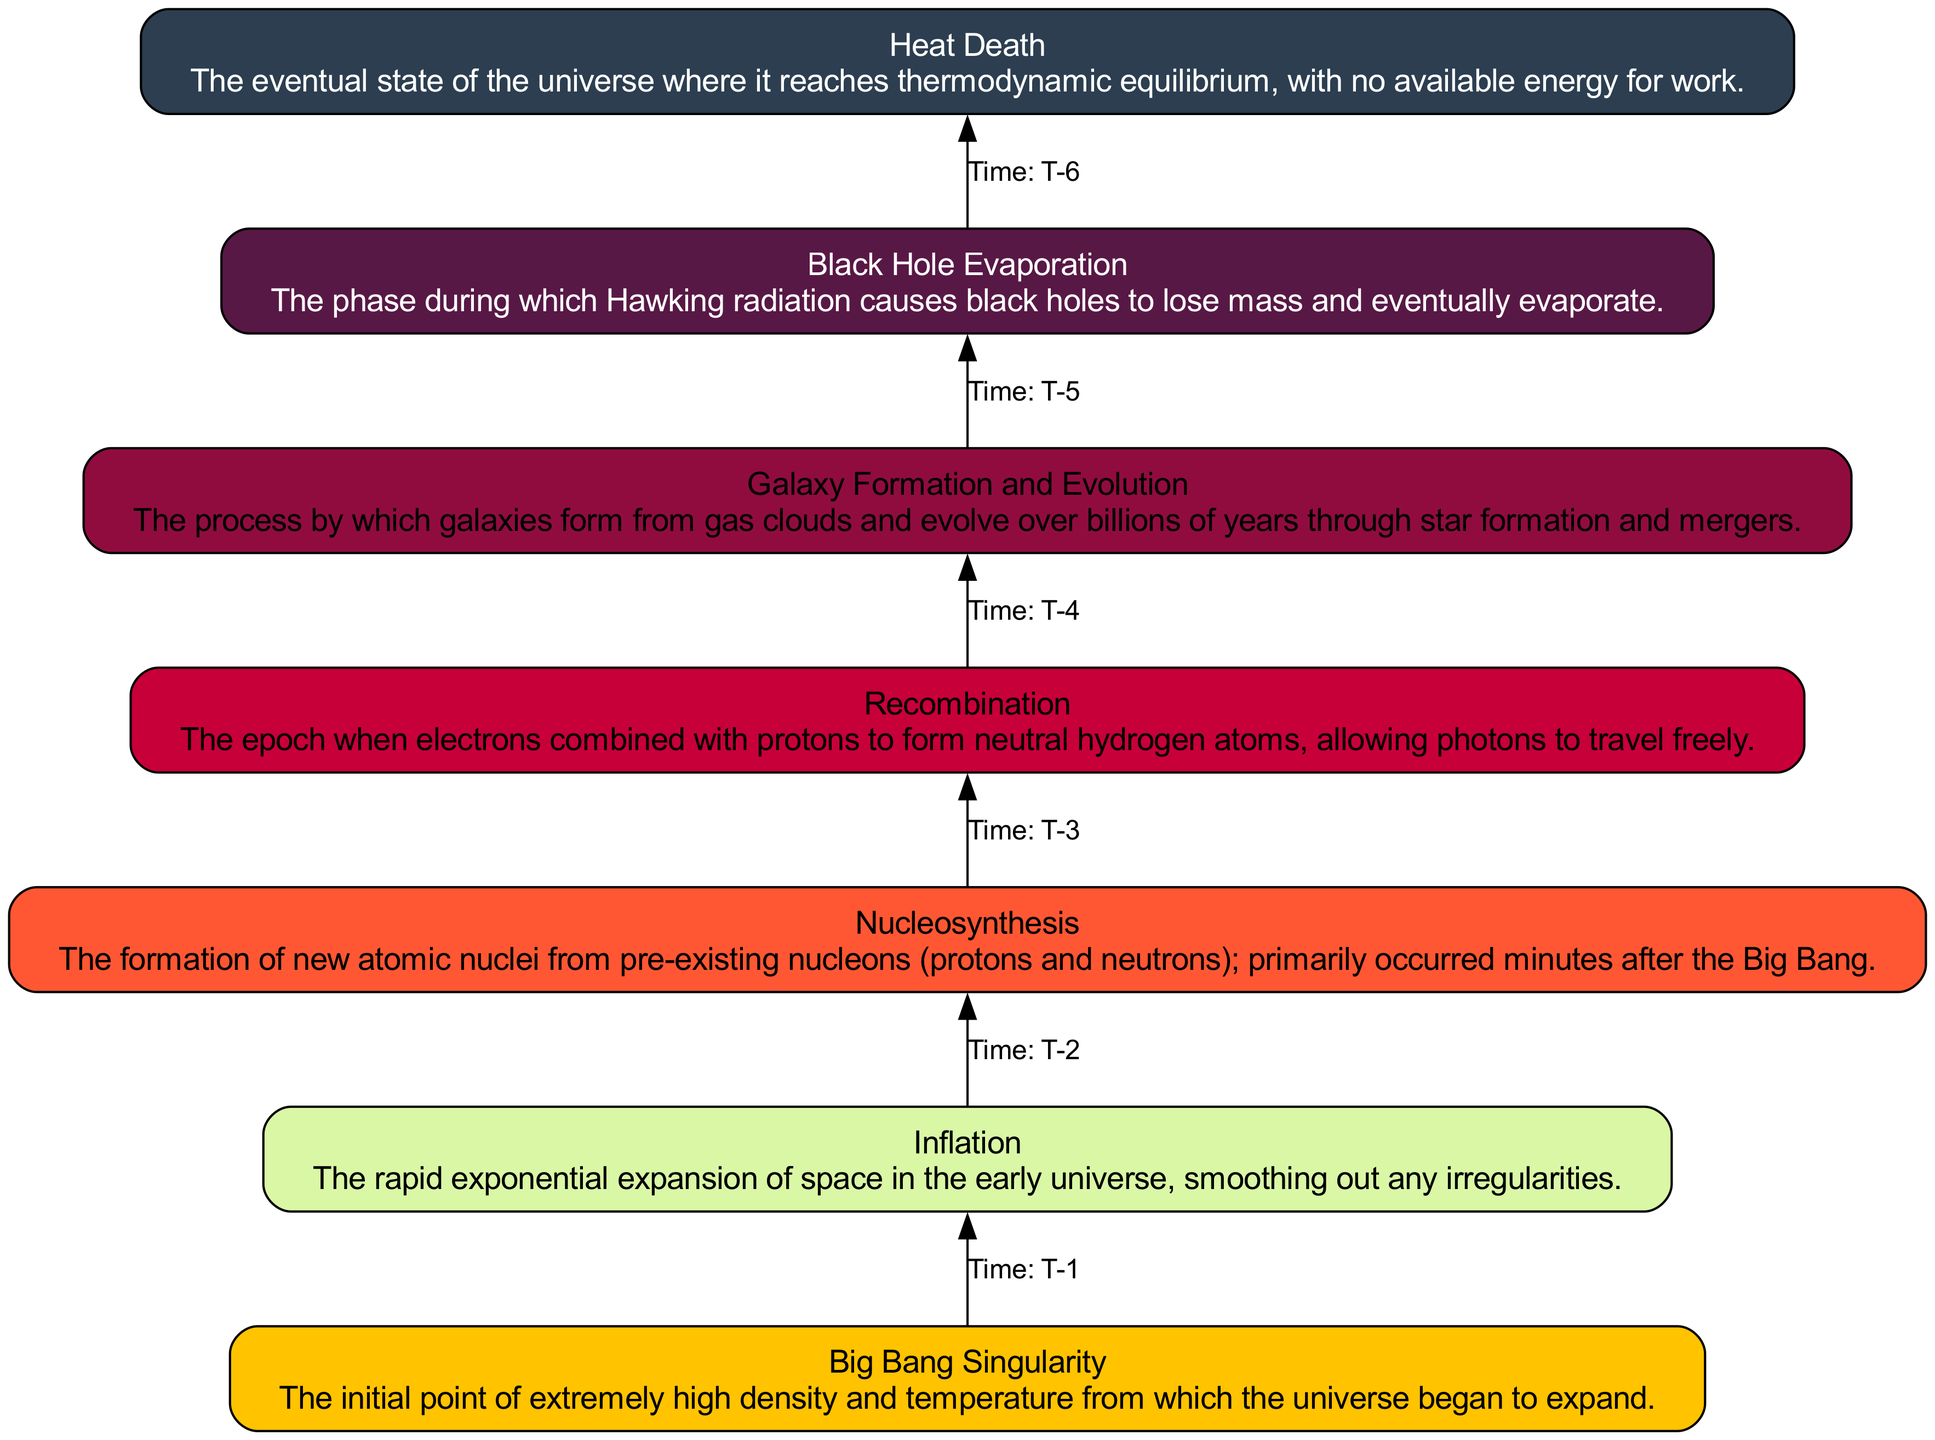What is the highest state in the flow chart? The highest state in the flow chart is represented by the "Heat Death" node, as it is placed at the topmost position, signifying the final outcome of the evolution of the universe.
Answer: Heat Death How many elements are in the flow chart? By counting each distinct node listed in the diagram, we find there are a total of seven elements present that outline the evolution of the universe.
Answer: 7 What is the second state from the top? The second state from the top is "Black Hole Evaporation," which directly follows the "Heat Death" in the flow chart. It highlights an intermediate process in the universe's final phases.
Answer: Black Hole Evaporation What process occurs immediately after "Nucleosynthesis"? The process that occurs immediately after "Nucleosynthesis" is "Recombination," indicating the sequence in the progression of the universe post-Big Bang.
Answer: Recombination What event marks the beginning of the universe? The event that marks the beginning of the universe is the "Big Bang Singularity," which is positioned at the very bottom of the flow chart, indicating its foundational role in cosmic evolution.
Answer: Big Bang Singularity What connection is present between "Galaxy Formation and Evolution" and "Black Hole Evaporation"? The connection between "Galaxy Formation and Evolution" and "Black Hole Evaporation" is established through their sequential positioning in the diagram, indicating a flow from the formation of galaxies to the eventual evaporation of black holes as part of universal evolution.
Answer: Time: T-3 Which node describes the epoch when neutral hydrogen atoms formed? The node that describes the epoch when neutral hydrogen atoms formed is "Recombination," which explicitly focuses on this critical phase in the cosmic timeline.
Answer: Recombination How does "Inflation" relate to the "Big Bang Singularity"? "Inflation" describes a rapid expansion phase that occurs just after the "Big Bang Singularity," effectively explaining the dynamics of the universe directly following its inception.
Answer: Inflation 